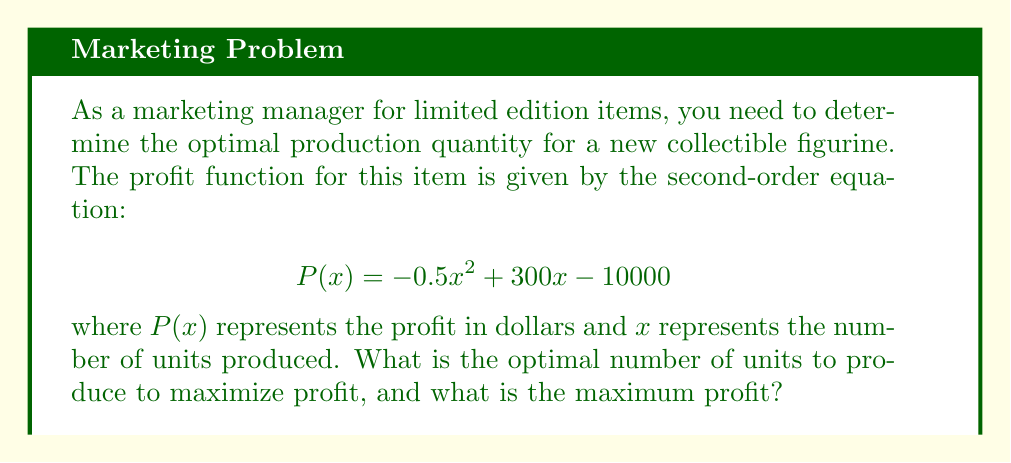Can you answer this question? To solve this problem, we need to follow these steps:

1. Recognize that the profit function is a quadratic equation, and its graph is a parabola that opens downward (because the coefficient of $x^2$ is negative).

2. The maximum point of this parabola occurs at its vertex, which represents the optimal number of units to produce for maximum profit.

3. To find the vertex, we can use the formula: $x = -\frac{b}{2a}$, where $a$ and $b$ are the coefficients of $x^2$ and $x$ respectively in the quadratic equation $ax^2 + bx + c$.

4. In this case, $a = -0.5$ and $b = 300$. Let's calculate:

   $$x = -\frac{300}{2(-0.5)} = -\frac{300}{-1} = 300$$

5. Therefore, the optimal number of units to produce is 300.

6. To find the maximum profit, we substitute $x = 300$ into the original profit function:

   $$\begin{align}
   P(300) &= -0.5(300)^2 + 300(300) - 10000 \\
   &= -0.5(90000) + 90000 - 10000 \\
   &= -45000 + 90000 - 10000 \\
   &= 35000
   \end{align}$$

Thus, the maximum profit is $35,000.
Answer: The optimal number of units to produce is 300, and the maximum profit is $35,000. 